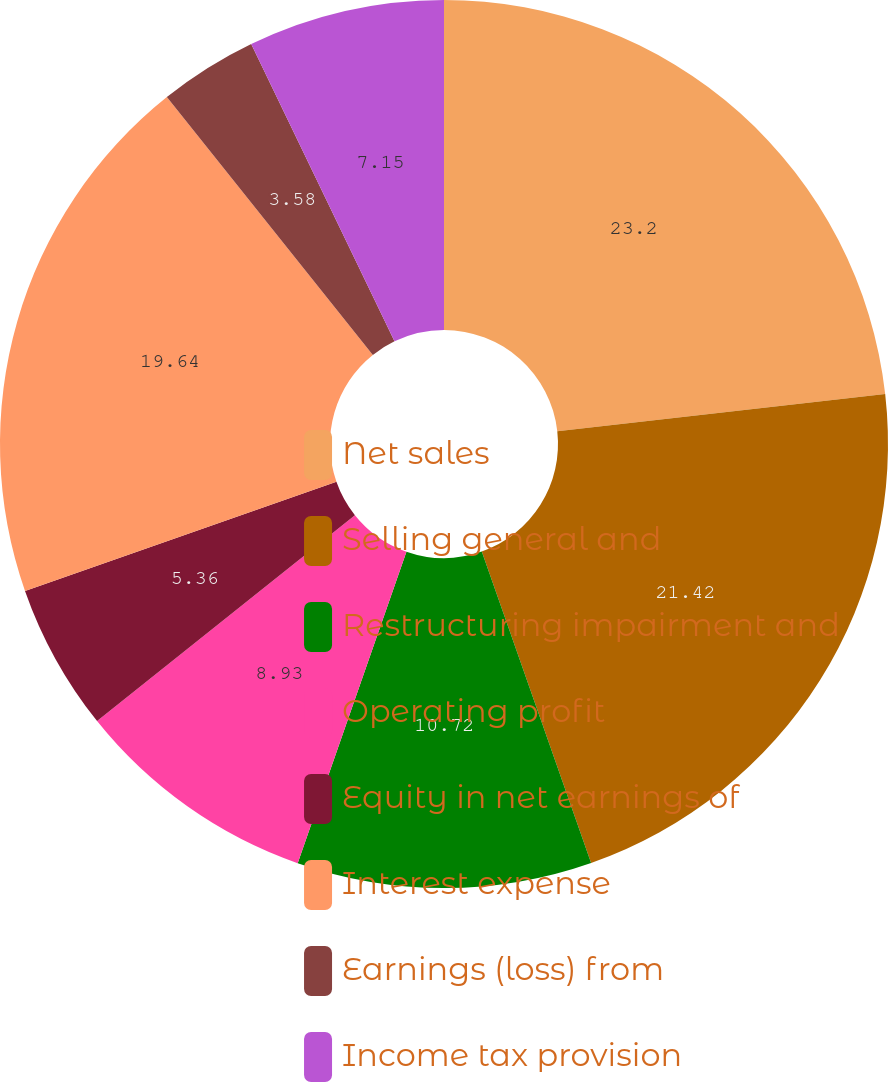Convert chart. <chart><loc_0><loc_0><loc_500><loc_500><pie_chart><fcel>Net sales<fcel>Selling general and<fcel>Restructuring impairment and<fcel>Operating profit<fcel>Equity in net earnings of<fcel>Interest expense<fcel>Earnings (loss) from<fcel>Income tax provision<nl><fcel>23.21%<fcel>21.42%<fcel>10.72%<fcel>8.93%<fcel>5.36%<fcel>19.64%<fcel>3.58%<fcel>7.15%<nl></chart> 